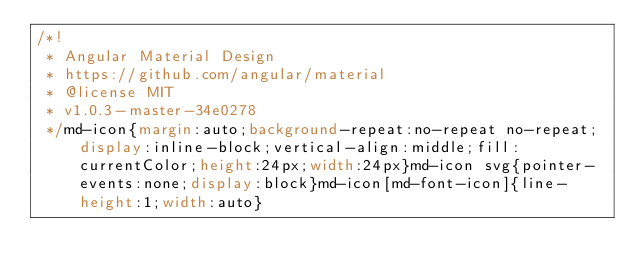<code> <loc_0><loc_0><loc_500><loc_500><_CSS_>/*!
 * Angular Material Design
 * https://github.com/angular/material
 * @license MIT
 * v1.0.3-master-34e0278
 */md-icon{margin:auto;background-repeat:no-repeat no-repeat;display:inline-block;vertical-align:middle;fill:currentColor;height:24px;width:24px}md-icon svg{pointer-events:none;display:block}md-icon[md-font-icon]{line-height:1;width:auto}</code> 